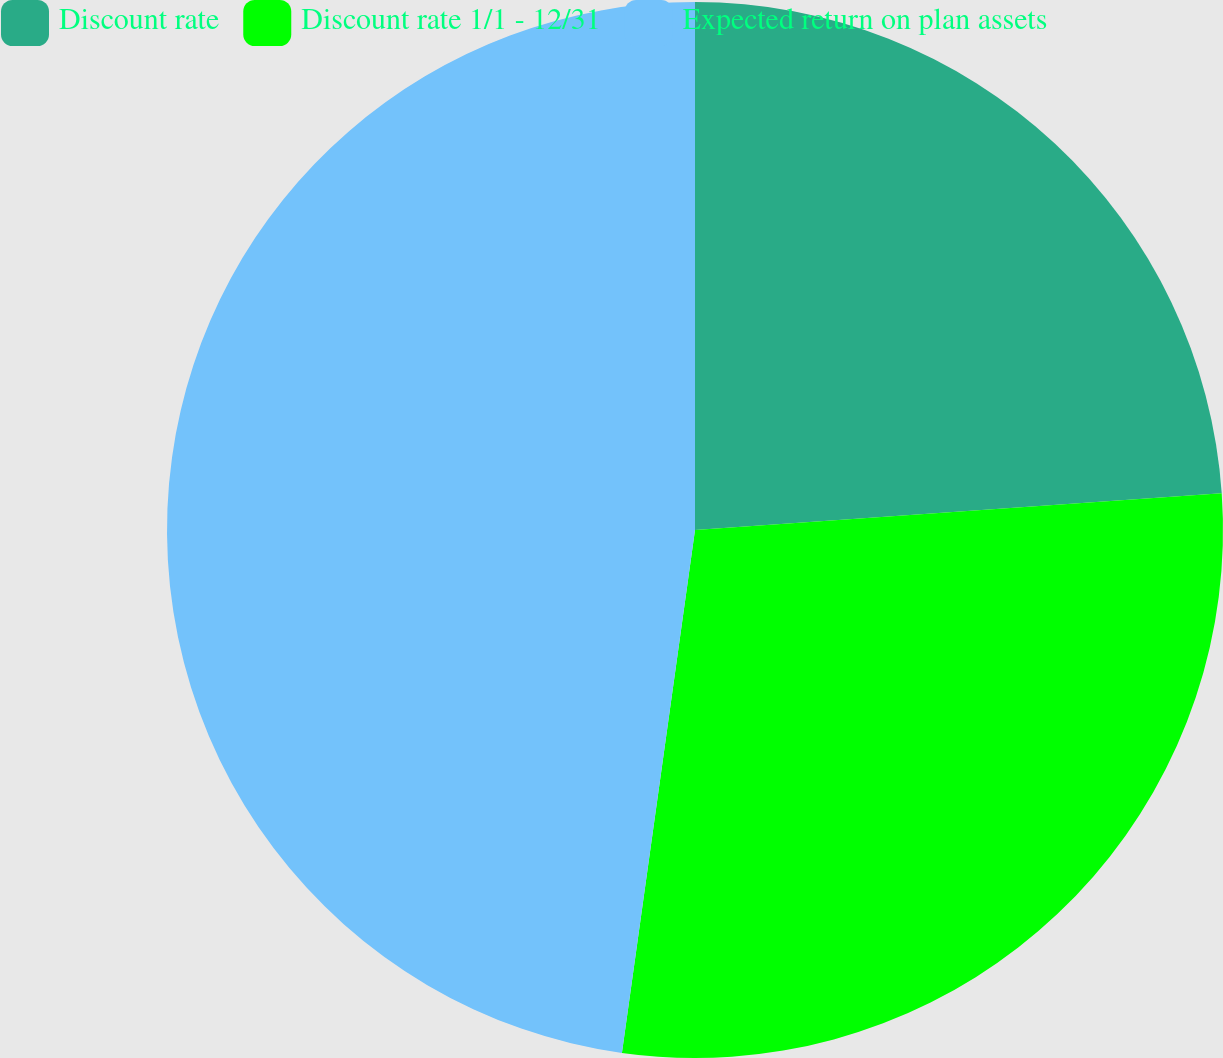<chart> <loc_0><loc_0><loc_500><loc_500><pie_chart><fcel>Discount rate<fcel>Discount rate 1/1 - 12/31<fcel>Expected return on plan assets<nl><fcel>23.89%<fcel>28.32%<fcel>47.79%<nl></chart> 